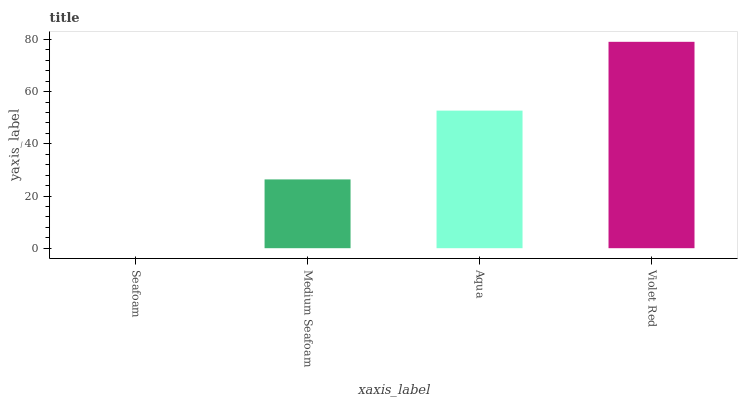Is Medium Seafoam the minimum?
Answer yes or no. No. Is Medium Seafoam the maximum?
Answer yes or no. No. Is Medium Seafoam greater than Seafoam?
Answer yes or no. Yes. Is Seafoam less than Medium Seafoam?
Answer yes or no. Yes. Is Seafoam greater than Medium Seafoam?
Answer yes or no. No. Is Medium Seafoam less than Seafoam?
Answer yes or no. No. Is Aqua the high median?
Answer yes or no. Yes. Is Medium Seafoam the low median?
Answer yes or no. Yes. Is Medium Seafoam the high median?
Answer yes or no. No. Is Seafoam the low median?
Answer yes or no. No. 